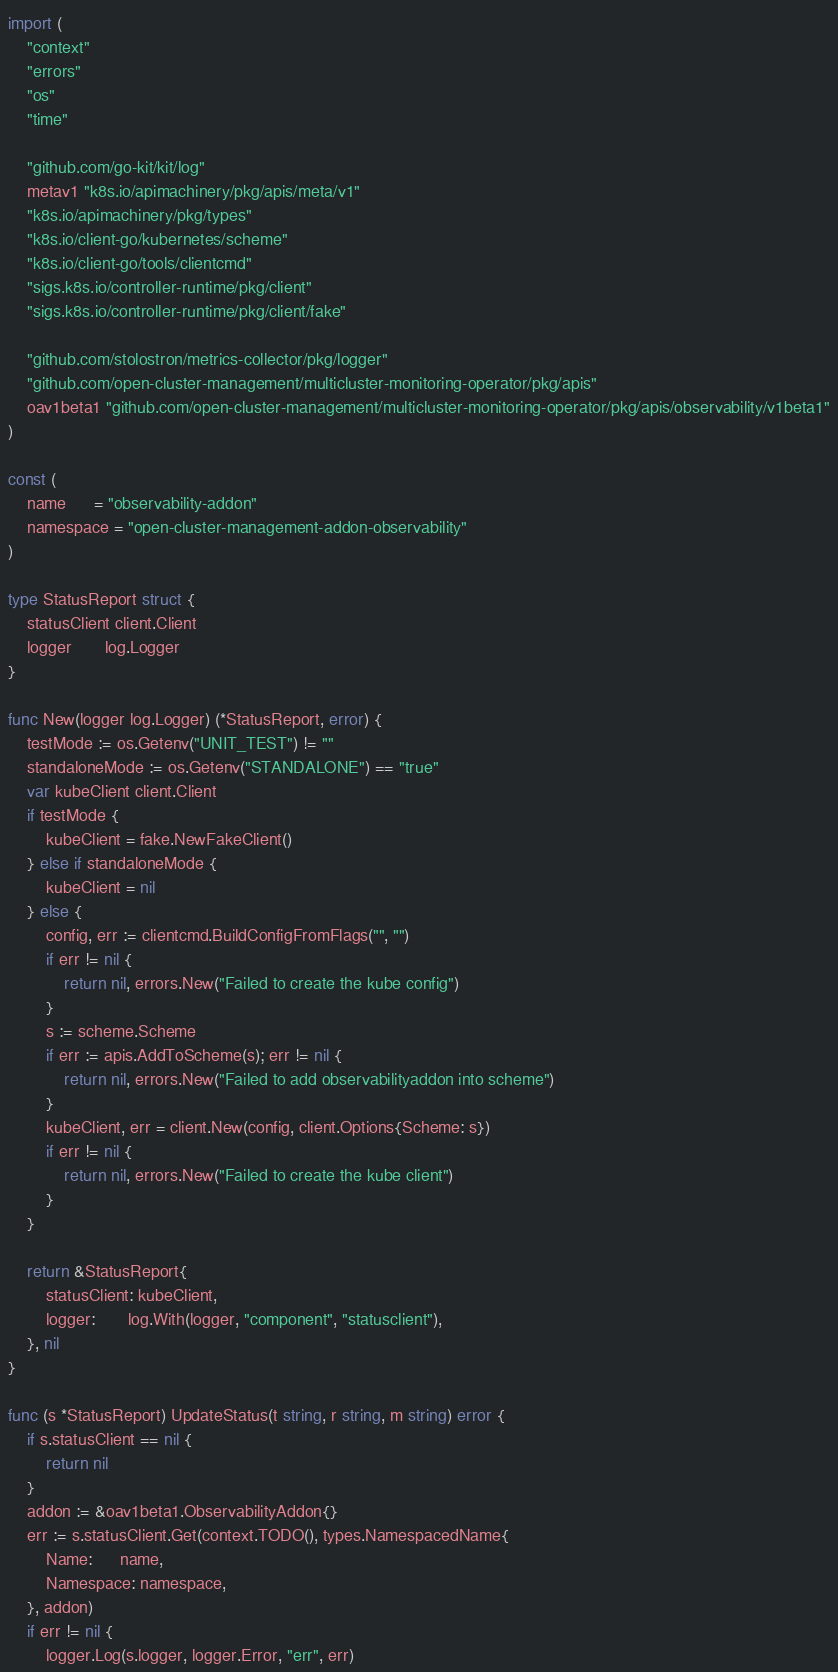<code> <loc_0><loc_0><loc_500><loc_500><_Go_>import (
	"context"
	"errors"
	"os"
	"time"

	"github.com/go-kit/kit/log"
	metav1 "k8s.io/apimachinery/pkg/apis/meta/v1"
	"k8s.io/apimachinery/pkg/types"
	"k8s.io/client-go/kubernetes/scheme"
	"k8s.io/client-go/tools/clientcmd"
	"sigs.k8s.io/controller-runtime/pkg/client"
	"sigs.k8s.io/controller-runtime/pkg/client/fake"

	"github.com/stolostron/metrics-collector/pkg/logger"
	"github.com/open-cluster-management/multicluster-monitoring-operator/pkg/apis"
	oav1beta1 "github.com/open-cluster-management/multicluster-monitoring-operator/pkg/apis/observability/v1beta1"
)

const (
	name      = "observability-addon"
	namespace = "open-cluster-management-addon-observability"
)

type StatusReport struct {
	statusClient client.Client
	logger       log.Logger
}

func New(logger log.Logger) (*StatusReport, error) {
	testMode := os.Getenv("UNIT_TEST") != ""
	standaloneMode := os.Getenv("STANDALONE") == "true"
	var kubeClient client.Client
	if testMode {
		kubeClient = fake.NewFakeClient()
	} else if standaloneMode {
		kubeClient = nil
	} else {
		config, err := clientcmd.BuildConfigFromFlags("", "")
		if err != nil {
			return nil, errors.New("Failed to create the kube config")
		}
		s := scheme.Scheme
		if err := apis.AddToScheme(s); err != nil {
			return nil, errors.New("Failed to add observabilityaddon into scheme")
		}
		kubeClient, err = client.New(config, client.Options{Scheme: s})
		if err != nil {
			return nil, errors.New("Failed to create the kube client")
		}
	}

	return &StatusReport{
		statusClient: kubeClient,
		logger:       log.With(logger, "component", "statusclient"),
	}, nil
}

func (s *StatusReport) UpdateStatus(t string, r string, m string) error {
	if s.statusClient == nil {
		return nil
	}
	addon := &oav1beta1.ObservabilityAddon{}
	err := s.statusClient.Get(context.TODO(), types.NamespacedName{
		Name:      name,
		Namespace: namespace,
	}, addon)
	if err != nil {
		logger.Log(s.logger, logger.Error, "err", err)</code> 